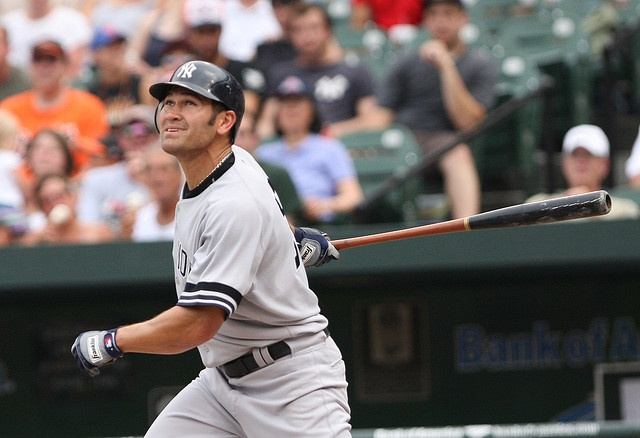Describe the objects in this image and their specific colors. I can see people in lightgray, darkgray, black, and gray tones, people in lightgray, lavender, tan, gray, and darkgray tones, people in lightgray, gray, black, and tan tones, people in lightgray, lavender, and gray tones, and people in lightgray, gray, tan, and darkgray tones in this image. 